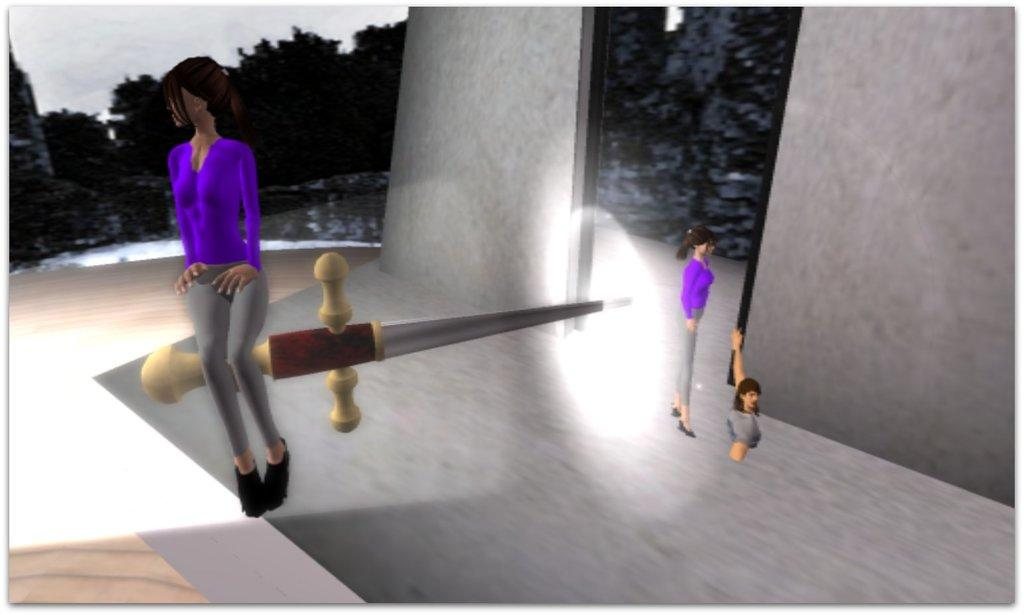What type of images can be seen in the picture? There are graphical images in the image. How many people are celebrating a birthday in the image? There is no information about a birthday or people in the image; it only mentions graphical images. 